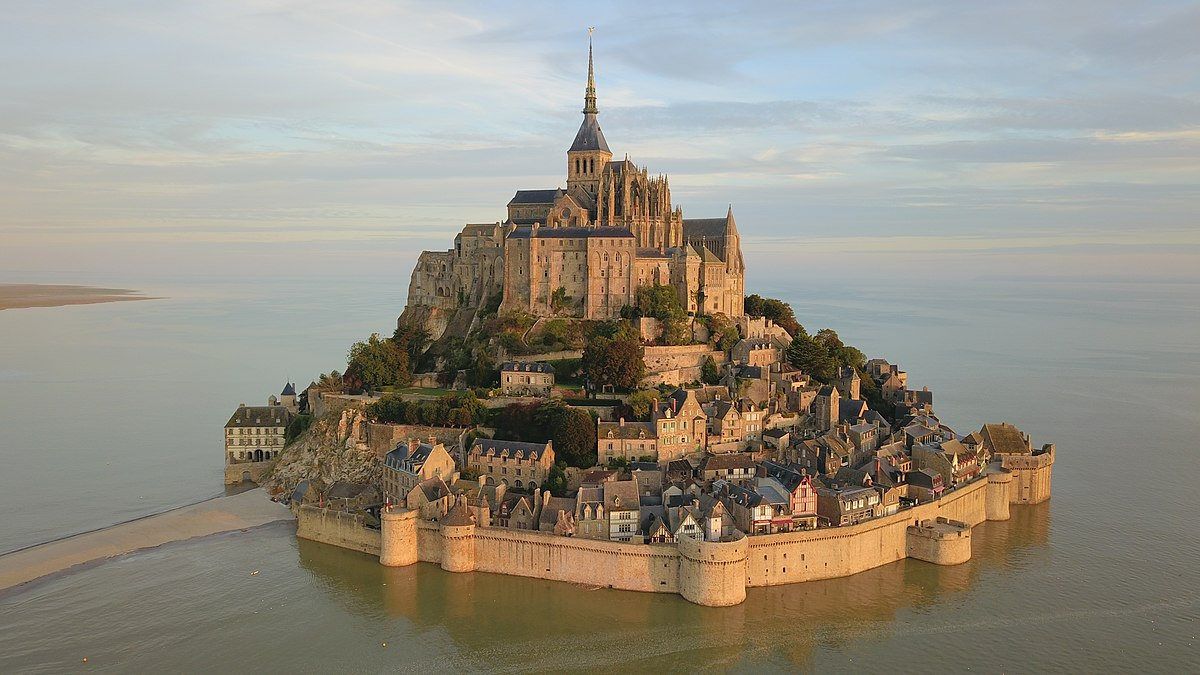Can you tell me about the different historical periods represented in Mont St Michel's architecture? Certainly! Mont St Michel's architecture is a tapestry of history, showcasing mainly Gothic, Romanesque, and medieval military architectural styles. The Romanesque influences are evident in the abbey's sturdy architecture dating back to the 11th century. Contributions from the Gothic period are visible in the lofty spire and the delicate flying buttresses that typify the later phases of construction. The fortress-like walls and defensive mechanisms around the island reflection its medieval military significance, designed to ward off hostile threats from the English during the Hundred Years' War. 